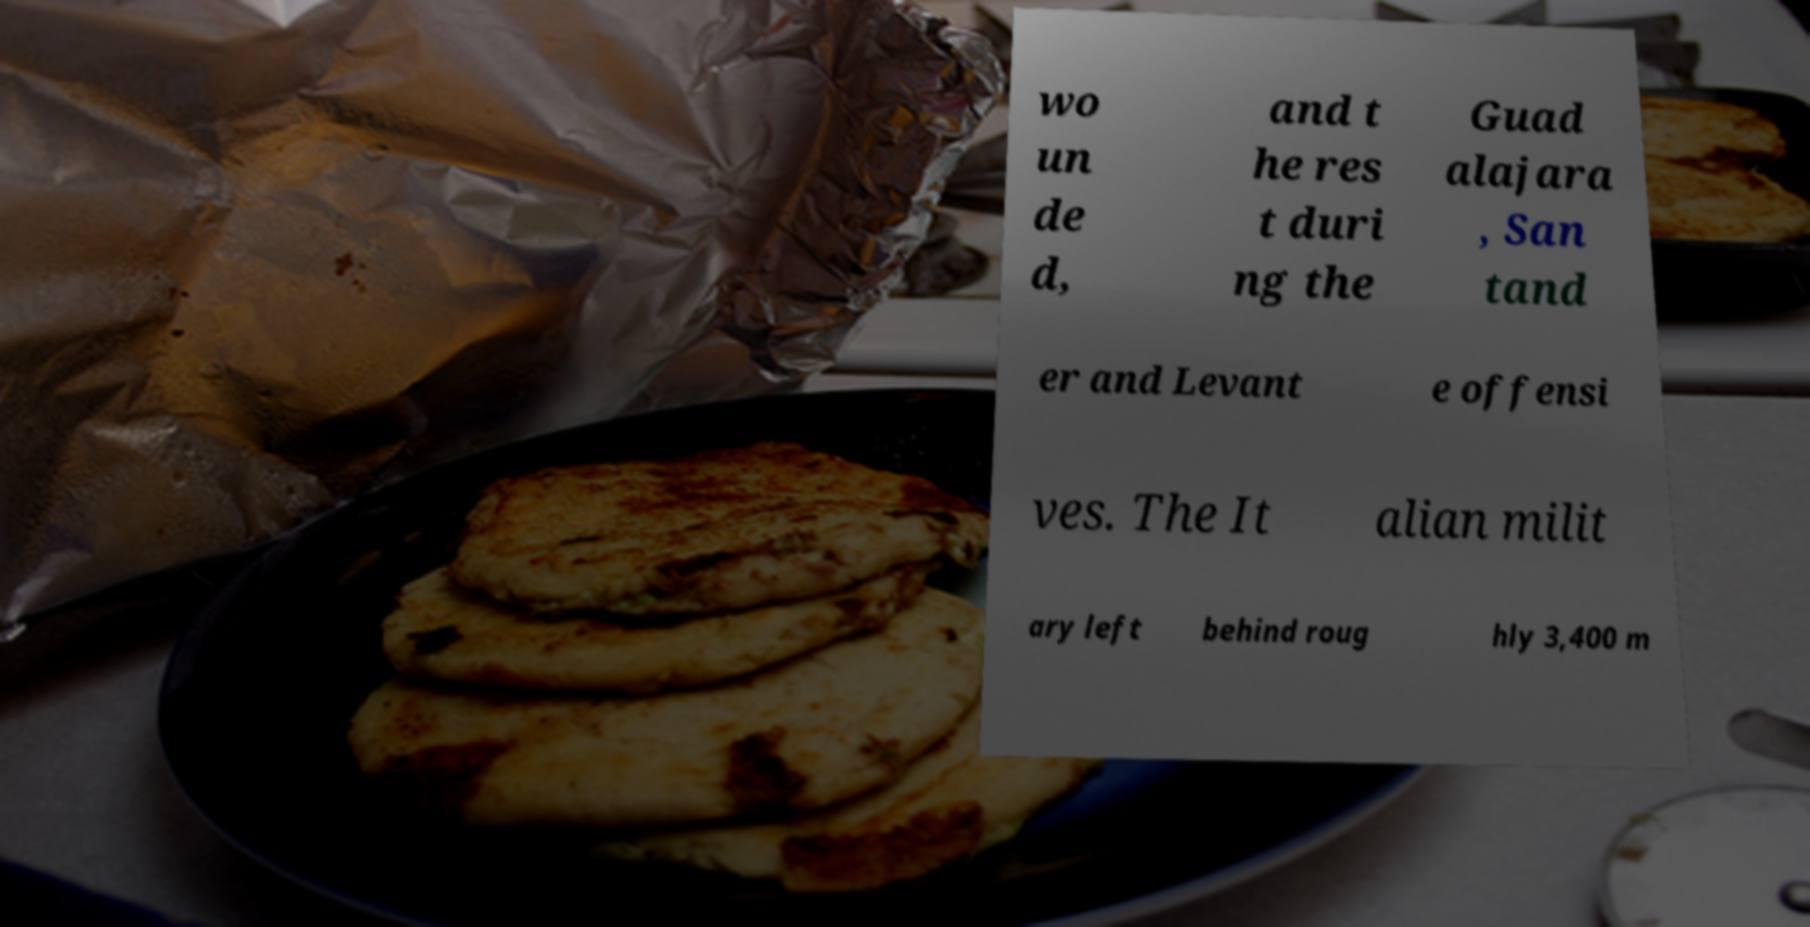Please read and relay the text visible in this image. What does it say? wo un de d, and t he res t duri ng the Guad alajara , San tand er and Levant e offensi ves. The It alian milit ary left behind roug hly 3,400 m 